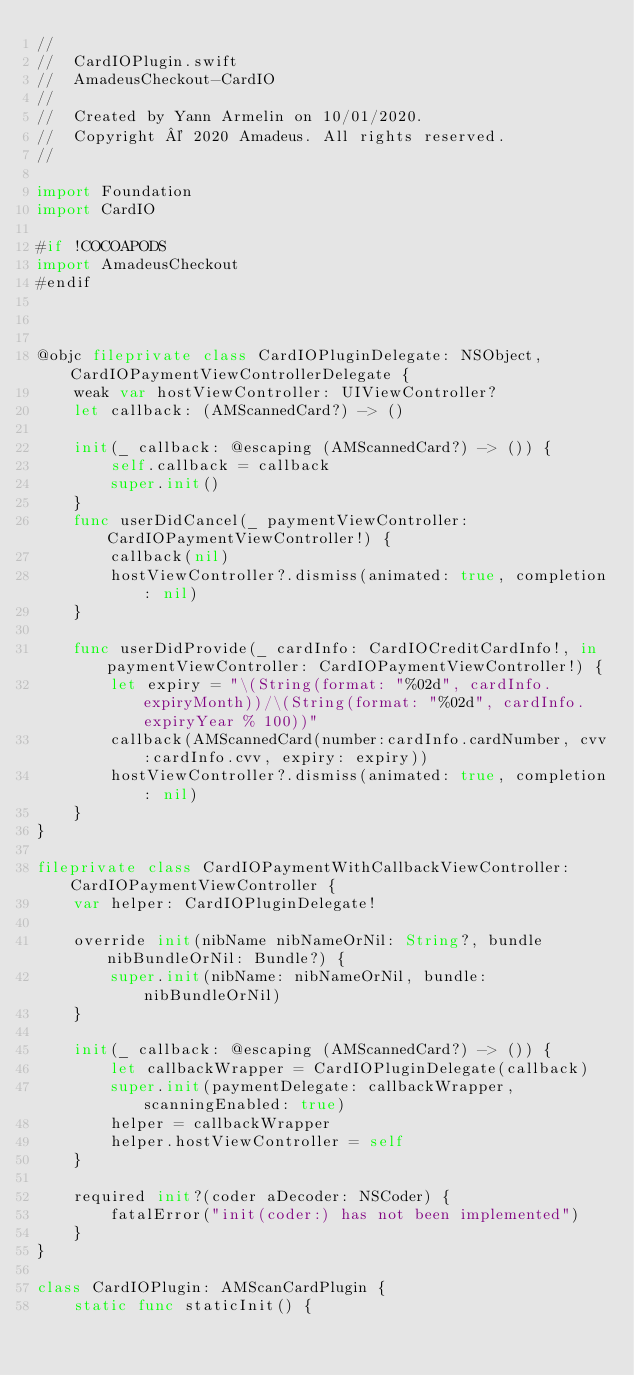Convert code to text. <code><loc_0><loc_0><loc_500><loc_500><_Swift_>//
//  CardIOPlugin.swift
//  AmadeusCheckout-CardIO
//
//  Created by Yann Armelin on 10/01/2020.
//  Copyright © 2020 Amadeus. All rights reserved.
//

import Foundation
import CardIO

#if !COCOAPODS
import AmadeusCheckout
#endif



@objc fileprivate class CardIOPluginDelegate: NSObject, CardIOPaymentViewControllerDelegate {
    weak var hostViewController: UIViewController?
    let callback: (AMScannedCard?) -> ()

    init(_ callback: @escaping (AMScannedCard?) -> ()) {
        self.callback = callback
        super.init()
    }
    func userDidCancel(_ paymentViewController: CardIOPaymentViewController!) {
        callback(nil)
        hostViewController?.dismiss(animated: true, completion: nil)
    }
    
    func userDidProvide(_ cardInfo: CardIOCreditCardInfo!, in paymentViewController: CardIOPaymentViewController!) {
        let expiry = "\(String(format: "%02d", cardInfo.expiryMonth))/\(String(format: "%02d", cardInfo.expiryYear % 100))"
        callback(AMScannedCard(number:cardInfo.cardNumber, cvv:cardInfo.cvv, expiry: expiry))
        hostViewController?.dismiss(animated: true, completion: nil)
    }
}

fileprivate class CardIOPaymentWithCallbackViewController: CardIOPaymentViewController {
    var helper: CardIOPluginDelegate!
    
    override init(nibName nibNameOrNil: String?, bundle nibBundleOrNil: Bundle?) {
        super.init(nibName: nibNameOrNil, bundle: nibBundleOrNil)
    }
    
    init(_ callback: @escaping (AMScannedCard?) -> ()) {
        let callbackWrapper = CardIOPluginDelegate(callback)
        super.init(paymentDelegate: callbackWrapper, scanningEnabled: true)
        helper = callbackWrapper
        helper.hostViewController = self
    }
    
    required init?(coder aDecoder: NSCoder) {
        fatalError("init(coder:) has not been implemented")
    }
}

class CardIOPlugin: AMScanCardPlugin {
    static func staticInit() {</code> 